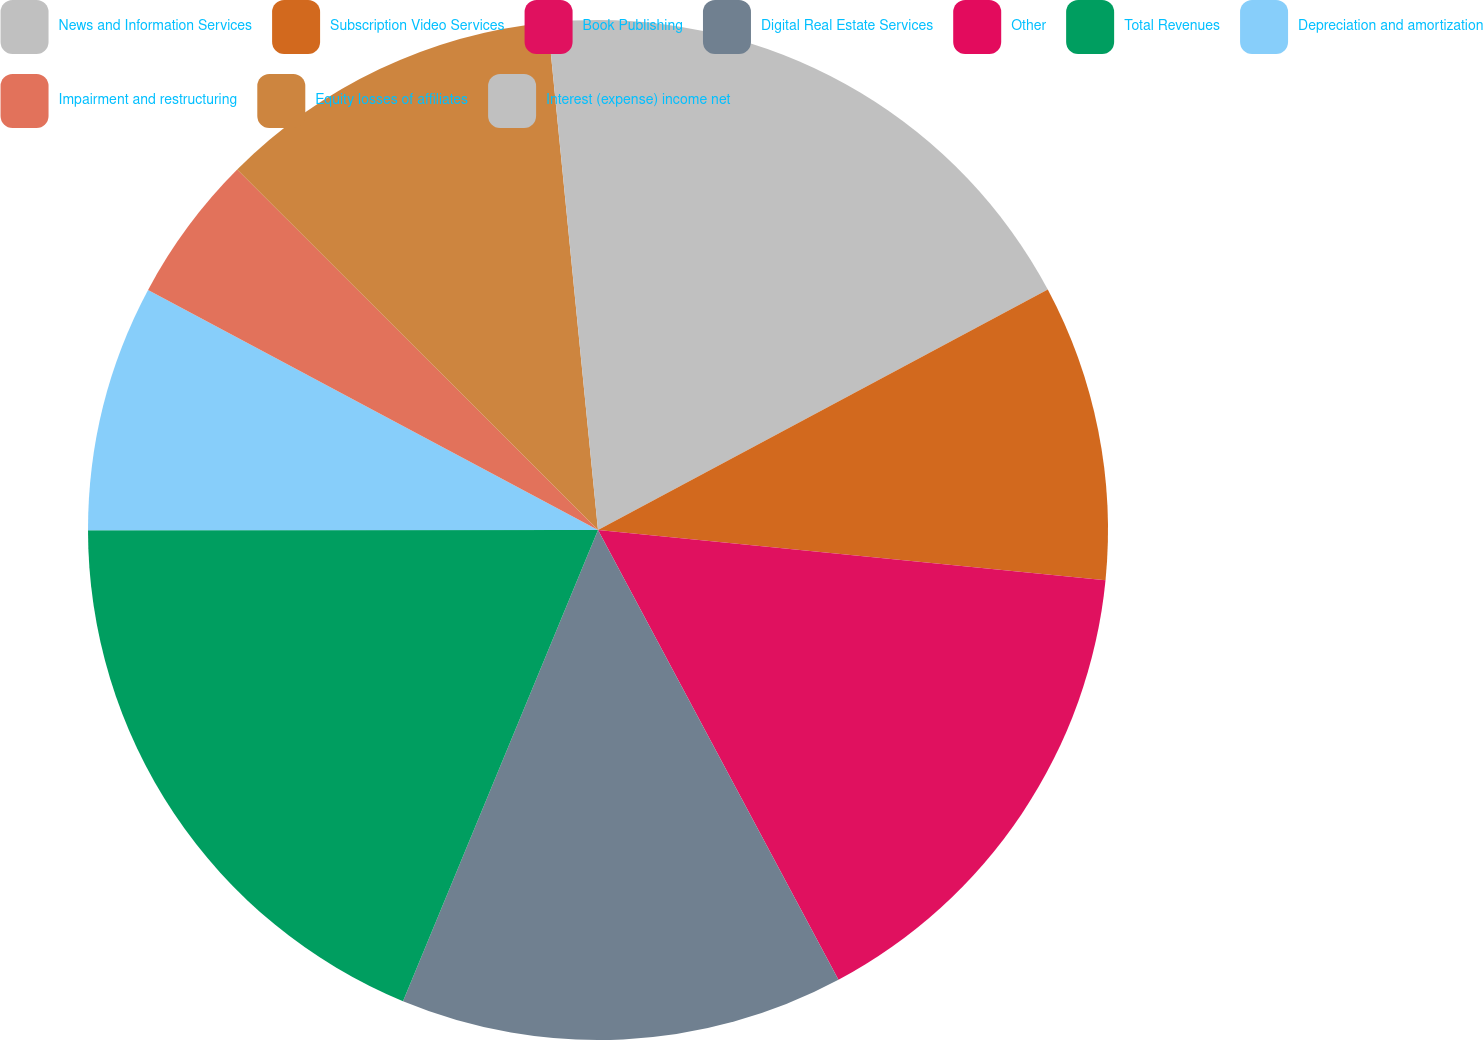Convert chart to OTSL. <chart><loc_0><loc_0><loc_500><loc_500><pie_chart><fcel>News and Information Services<fcel>Subscription Video Services<fcel>Book Publishing<fcel>Digital Real Estate Services<fcel>Other<fcel>Total Revenues<fcel>Depreciation and amortization<fcel>Impairment and restructuring<fcel>Equity losses of affiliates<fcel>Interest (expense) income net<nl><fcel>17.19%<fcel>9.38%<fcel>15.62%<fcel>14.06%<fcel>0.0%<fcel>18.75%<fcel>7.81%<fcel>4.69%<fcel>10.94%<fcel>1.57%<nl></chart> 